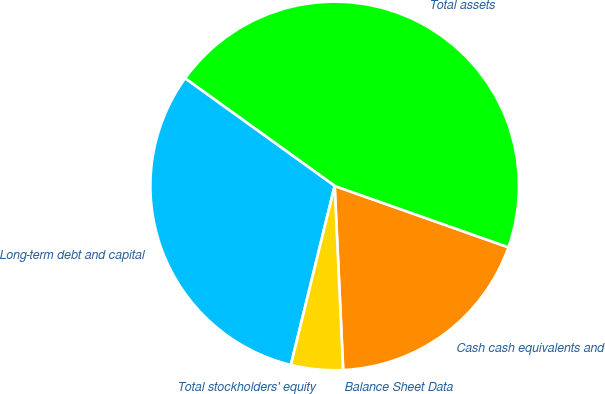Convert chart. <chart><loc_0><loc_0><loc_500><loc_500><pie_chart><fcel>Balance Sheet Data<fcel>Cash cash equivalents and<fcel>Total assets<fcel>Long-term debt and capital<fcel>Total stockholders' equity<nl><fcel>0.01%<fcel>18.86%<fcel>45.48%<fcel>31.11%<fcel>4.55%<nl></chart> 